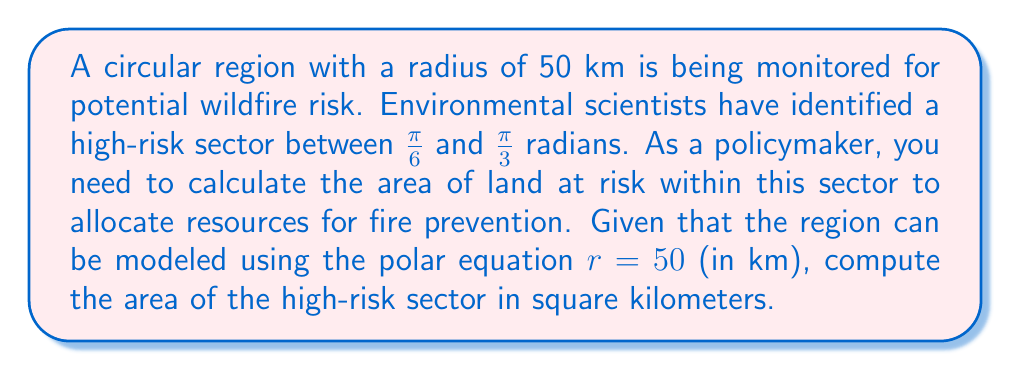Can you answer this question? To solve this problem, we'll use the formula for the area of a sector in polar coordinates:

$$A = \frac{1}{2} \int_{\theta_1}^{\theta_2} r^2 d\theta$$

Where:
- $A$ is the area of the sector
- $r$ is the radius (given by the polar equation)
- $\theta_1$ and $\theta_2$ are the starting and ending angles of the sector

Steps:
1) Identify the given information:
   - $r = 50$ km
   - $\theta_1 = \frac{\pi}{6}$
   - $\theta_2 = \frac{\pi}{3}$

2) Substitute these values into the formula:

   $$A = \frac{1}{2} \int_{\frac{\pi}{6}}^{\frac{\pi}{3}} 50^2 d\theta$$

3) Simplify the integral:

   $$A = \frac{1}{2} \cdot 2500 \int_{\frac{\pi}{6}}^{\frac{\pi}{3}} d\theta$$

4) Evaluate the integral:

   $$A = 1250 \left[\theta\right]_{\frac{\pi}{6}}^{\frac{\pi}{3}}$$

5) Substitute the limits and calculate:

   $$A = 1250 \left(\frac{\pi}{3} - \frac{\pi}{6}\right) = 1250 \cdot \frac{\pi}{6}$$

6) Simplify:

   $$A = \frac{1250\pi}{6} \approx 654.50 \text{ km}^2$$

Thus, the area of the high-risk sector is approximately 654.50 square kilometers.
Answer: $\frac{1250\pi}{6} \approx 654.50 \text{ km}^2$ 